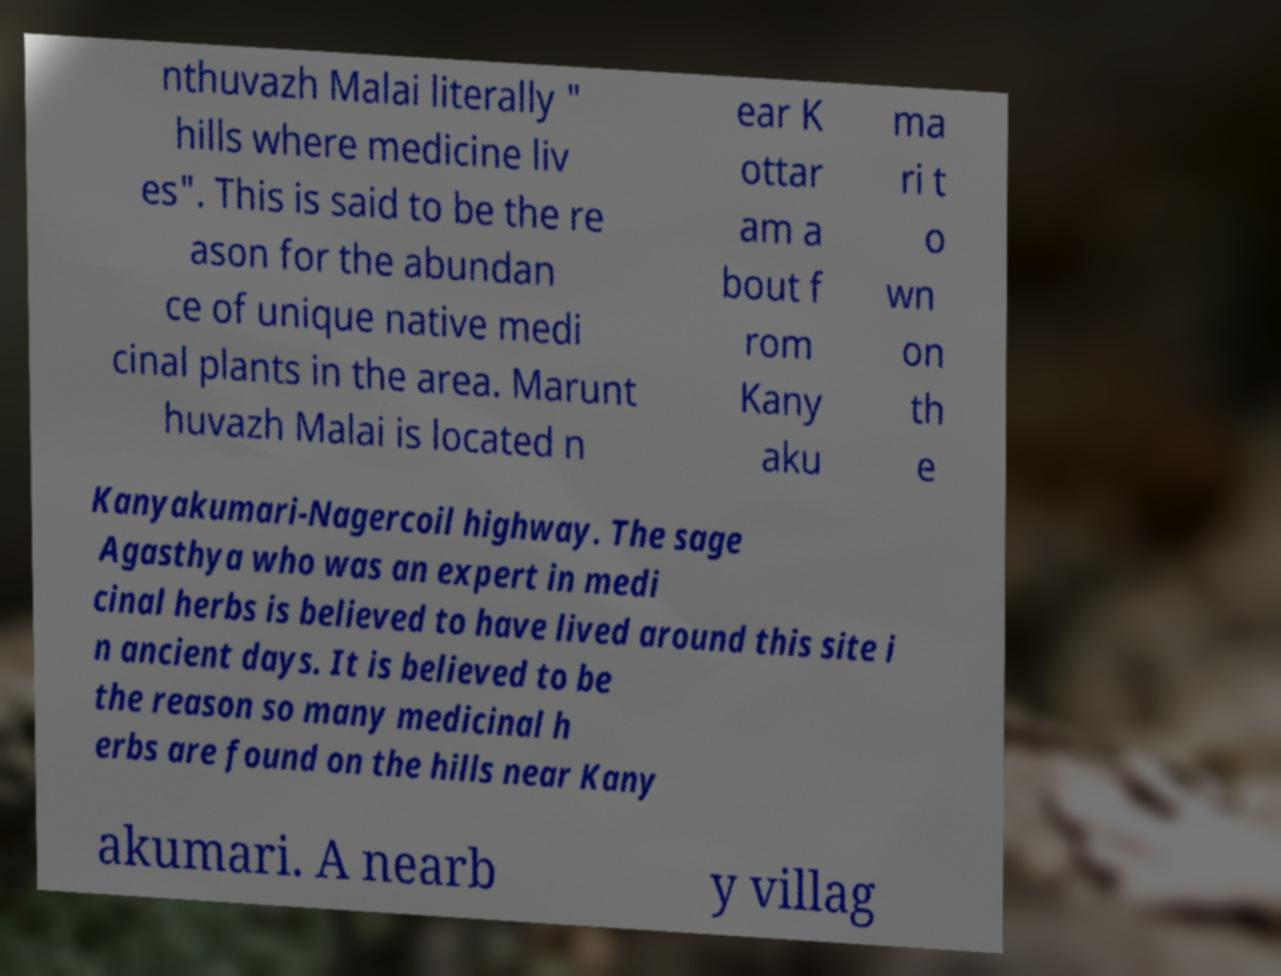I need the written content from this picture converted into text. Can you do that? nthuvazh Malai literally " hills where medicine liv es". This is said to be the re ason for the abundan ce of unique native medi cinal plants in the area. Marunt huvazh Malai is located n ear K ottar am a bout f rom Kany aku ma ri t o wn on th e Kanyakumari-Nagercoil highway. The sage Agasthya who was an expert in medi cinal herbs is believed to have lived around this site i n ancient days. It is believed to be the reason so many medicinal h erbs are found on the hills near Kany akumari. A nearb y villag 